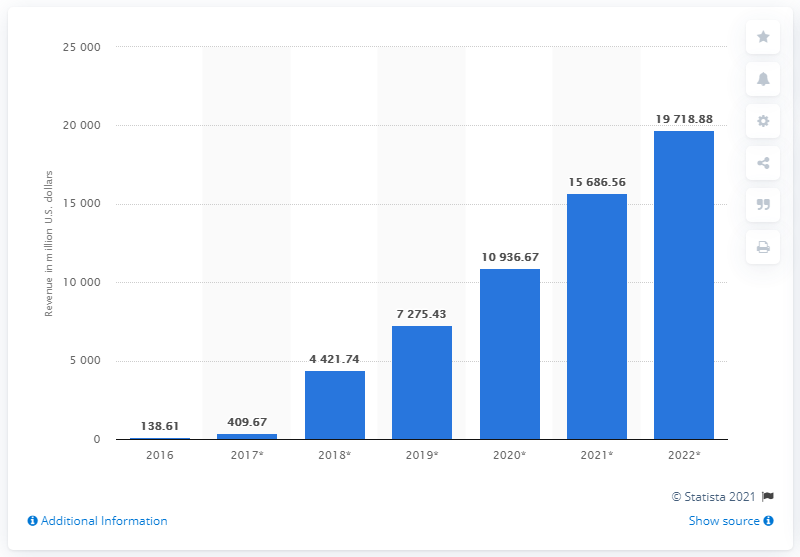Indicate a few pertinent items in this graphic. The projected amount of smart AR glasses revenue by 2022 is expected to be 19,718.88. In 2016, the revenue generated by smart AR glasses in the United States was approximately $138.61 million. 